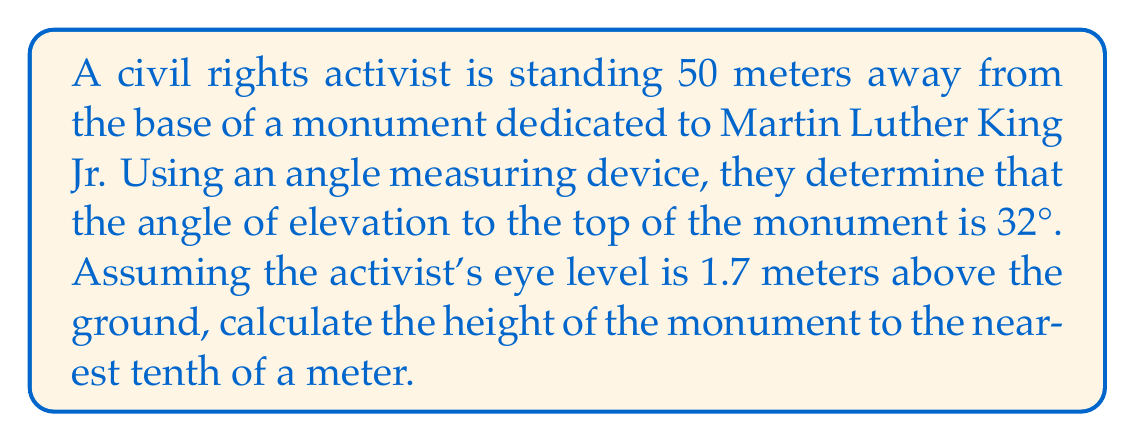Teach me how to tackle this problem. Let's approach this step-by-step using trigonometric ratios:

1) First, let's visualize the problem:

[asy]
import geometry;

size(200);

pair A = (0,0), B = (10,0), C = (10,7), D = (10,0.34);
draw(A--B--C--A);
draw(A--D, dashed);

label("50 m", (A--B), S);
label("h", (B--C), E);
label("1.7 m", (B--D), E);
label("32°", (0,0), NE);

dot("A", A, SW);
dot("B", B, SE);
dot("C", C, NE);
dot("D", D, E);
[/asy]

2) We need to find the height of the monument (BC in the diagram). We already know:
   - The distance from the activist to the base (AB) = 50 meters
   - The angle of elevation (∠BAC) = 32°
   - The height of the activist's eye level (BD) = 1.7 meters

3) We can use the tangent ratio to find the height. Tangent is the ratio of the opposite side to the adjacent side in a right triangle.

   $$\tan(\theta) = \frac{\text{opposite}}{\text{adjacent}}$$

4) In this case:
   $$\tan(32°) = \frac{\text{DC}}{50}$$

5) Rearranging this equation:
   $$\text{DC} = 50 \tan(32°)$$

6) Using a calculator:
   $$\text{DC} = 50 \times 0.6249 = 31.245$$

7) But this is only the height from the activist's eye level to the top of the monument. We need to add the activist's eye level height:

   $$\text{Total Height} = \text{DC} + \text{BD} = 31.245 + 1.7 = 32.945$$

8) Rounding to the nearest tenth:
   $$\text{Height of monument} \approx 32.9 \text{ meters}$$
Answer: $32.9 \text{ meters}$ 